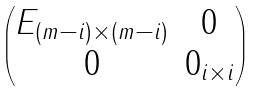<formula> <loc_0><loc_0><loc_500><loc_500>\begin{pmatrix} E _ { ( m - i ) \times ( m - i ) } & 0 \\ 0 & 0 _ { i \times i } \end{pmatrix}</formula> 